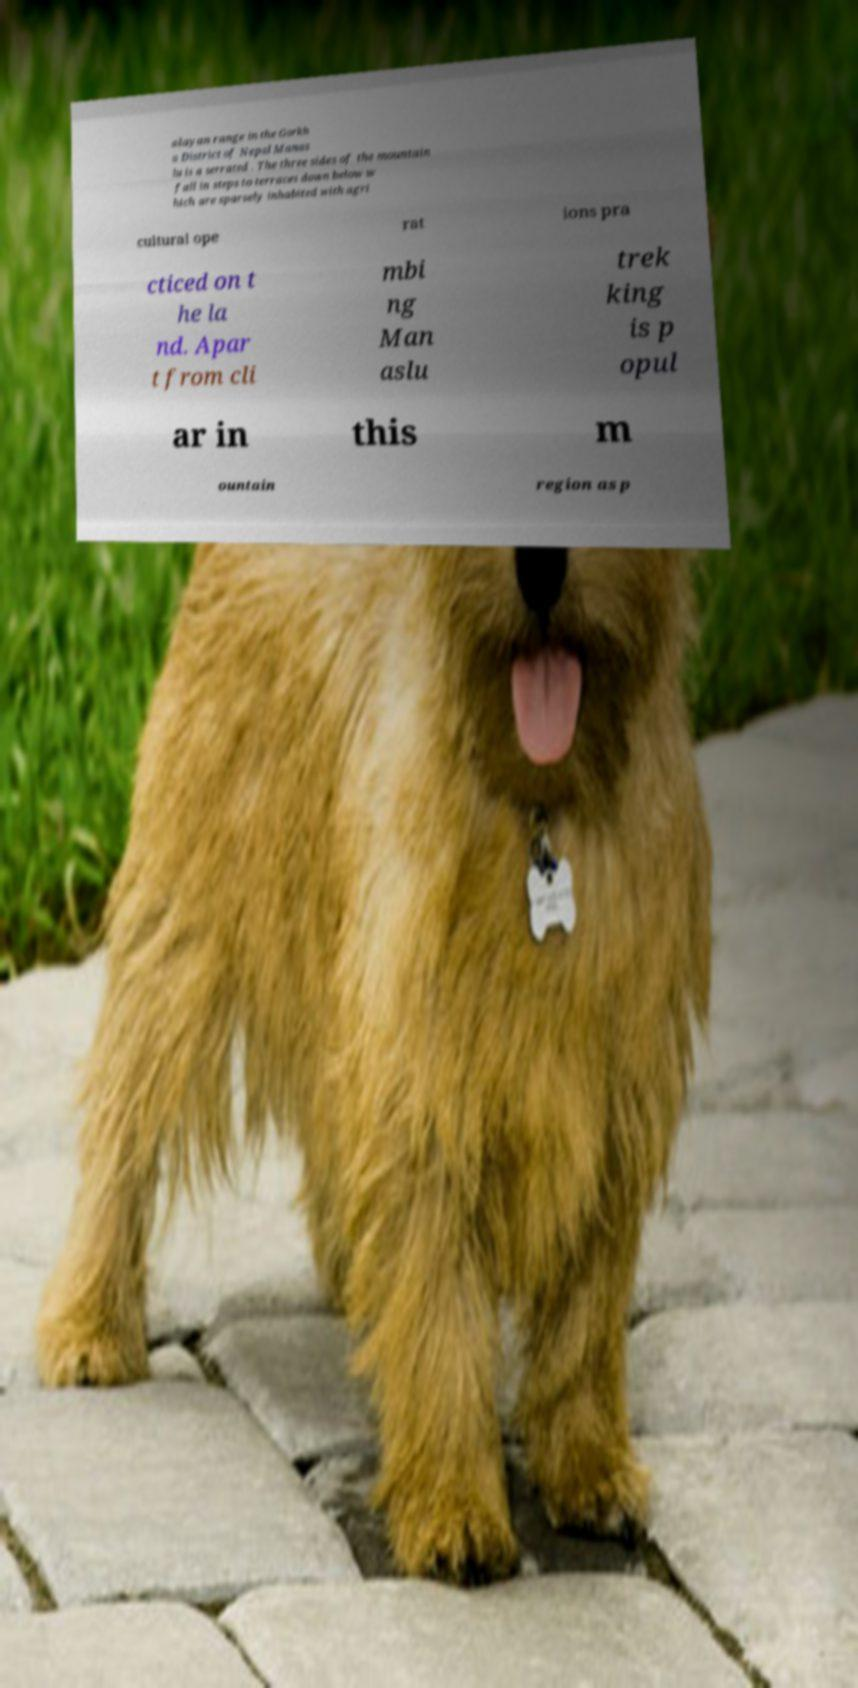Please identify and transcribe the text found in this image. alayan range in the Gorkh a District of Nepal Manas lu is a serrated . The three sides of the mountain fall in steps to terraces down below w hich are sparsely inhabited with agri cultural ope rat ions pra cticed on t he la nd. Apar t from cli mbi ng Man aslu trek king is p opul ar in this m ountain region as p 